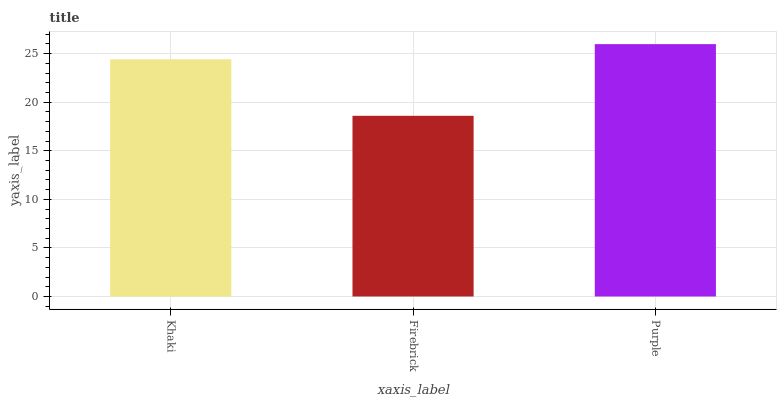Is Purple the minimum?
Answer yes or no. No. Is Firebrick the maximum?
Answer yes or no. No. Is Purple greater than Firebrick?
Answer yes or no. Yes. Is Firebrick less than Purple?
Answer yes or no. Yes. Is Firebrick greater than Purple?
Answer yes or no. No. Is Purple less than Firebrick?
Answer yes or no. No. Is Khaki the high median?
Answer yes or no. Yes. Is Khaki the low median?
Answer yes or no. Yes. Is Firebrick the high median?
Answer yes or no. No. Is Firebrick the low median?
Answer yes or no. No. 